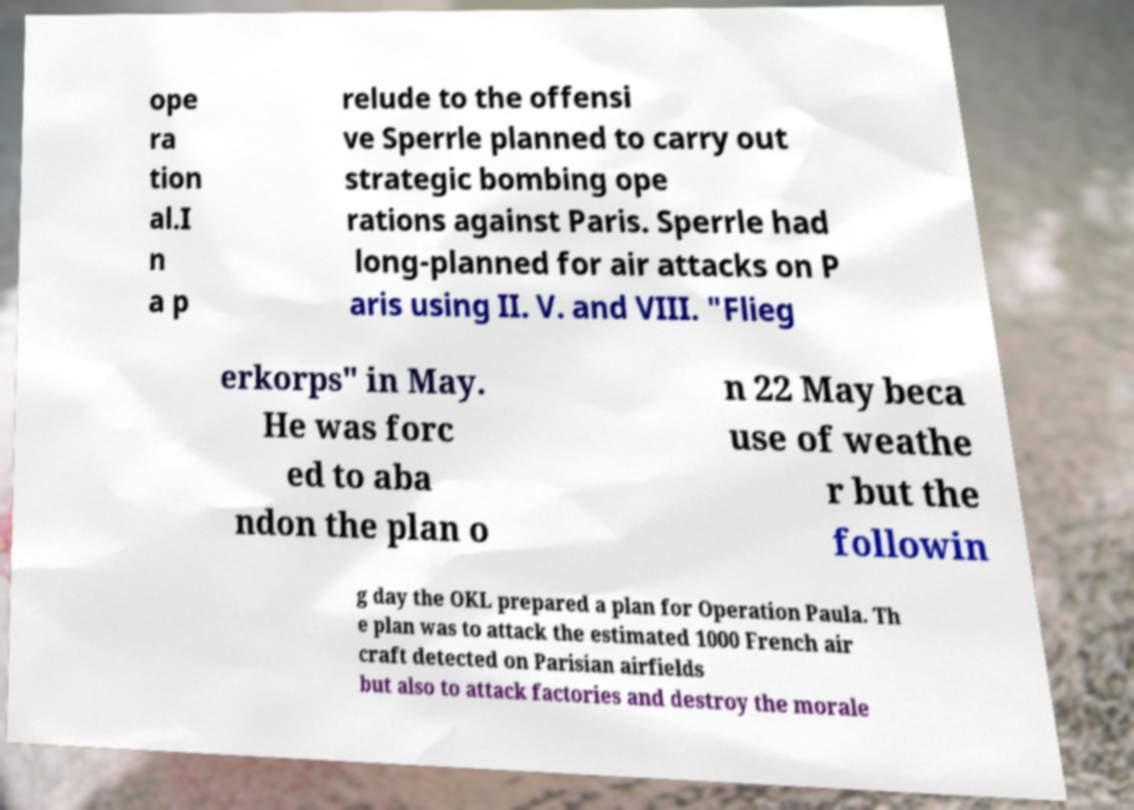Could you extract and type out the text from this image? ope ra tion al.I n a p relude to the offensi ve Sperrle planned to carry out strategic bombing ope rations against Paris. Sperrle had long-planned for air attacks on P aris using II. V. and VIII. "Flieg erkorps" in May. He was forc ed to aba ndon the plan o n 22 May beca use of weathe r but the followin g day the OKL prepared a plan for Operation Paula. Th e plan was to attack the estimated 1000 French air craft detected on Parisian airfields but also to attack factories and destroy the morale 